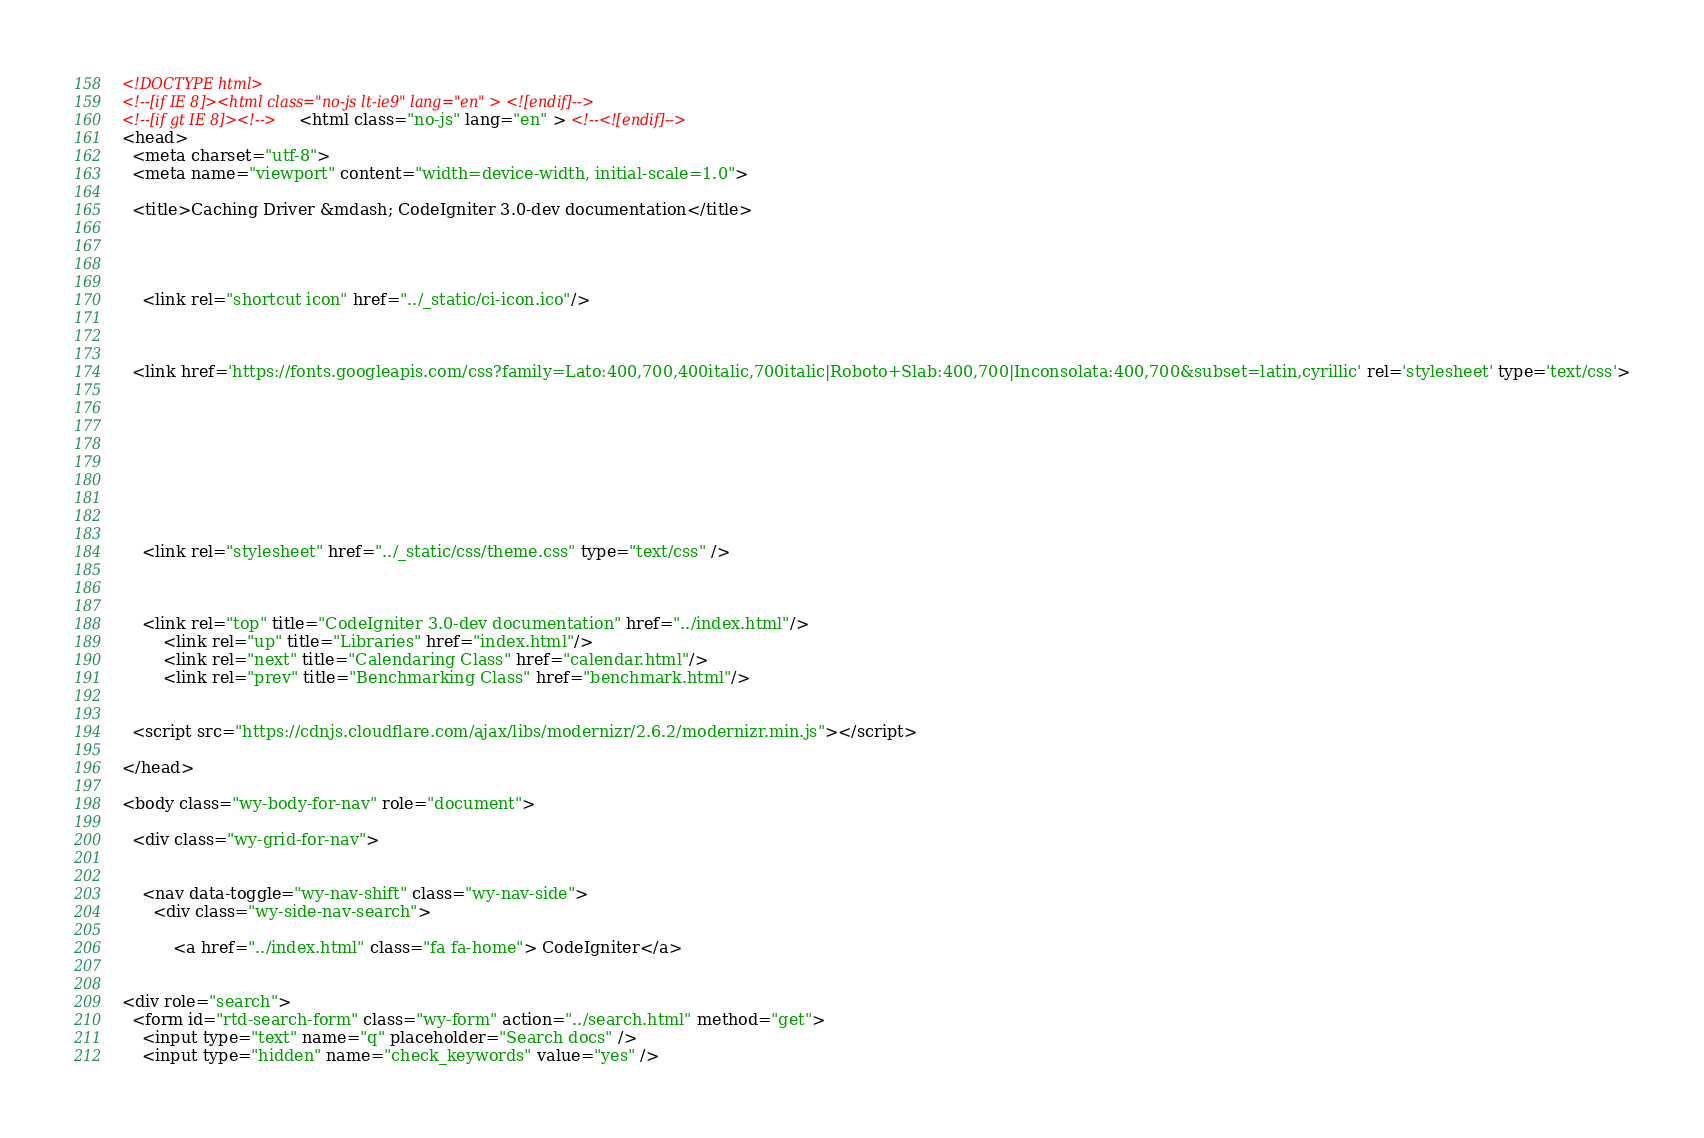Convert code to text. <code><loc_0><loc_0><loc_500><loc_500><_HTML_>

<!DOCTYPE html>
<!--[if IE 8]><html class="no-js lt-ie9" lang="en" > <![endif]-->
<!--[if gt IE 8]><!--> <html class="no-js" lang="en" > <!--<![endif]-->
<head>
  <meta charset="utf-8">
  <meta name="viewport" content="width=device-width, initial-scale=1.0">
  
  <title>Caching Driver &mdash; CodeIgniter 3.0-dev documentation</title>
  

  
  
    <link rel="shortcut icon" href="../_static/ci-icon.ico"/>
  

  
  <link href='https://fonts.googleapis.com/css?family=Lato:400,700,400italic,700italic|Roboto+Slab:400,700|Inconsolata:400,700&subset=latin,cyrillic' rel='stylesheet' type='text/css'>

  
  
    

  

  
  
    <link rel="stylesheet" href="../_static/css/theme.css" type="text/css" />
  

  
    <link rel="top" title="CodeIgniter 3.0-dev documentation" href="../index.html"/>
        <link rel="up" title="Libraries" href="index.html"/>
        <link rel="next" title="Calendaring Class" href="calendar.html"/>
        <link rel="prev" title="Benchmarking Class" href="benchmark.html"/> 

  
  <script src="https://cdnjs.cloudflare.com/ajax/libs/modernizr/2.6.2/modernizr.min.js"></script>

</head>

<body class="wy-body-for-nav" role="document">

  <div class="wy-grid-for-nav">

    
    <nav data-toggle="wy-nav-shift" class="wy-nav-side">
      <div class="wy-side-nav-search">
        
          <a href="../index.html" class="fa fa-home"> CodeIgniter</a>
        
        
<div role="search">
  <form id="rtd-search-form" class="wy-form" action="../search.html" method="get">
    <input type="text" name="q" placeholder="Search docs" />
    <input type="hidden" name="check_keywords" value="yes" /></code> 